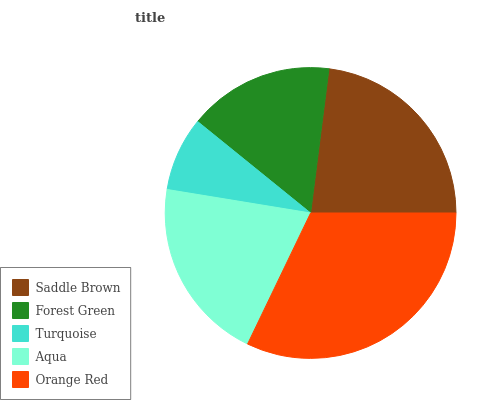Is Turquoise the minimum?
Answer yes or no. Yes. Is Orange Red the maximum?
Answer yes or no. Yes. Is Forest Green the minimum?
Answer yes or no. No. Is Forest Green the maximum?
Answer yes or no. No. Is Saddle Brown greater than Forest Green?
Answer yes or no. Yes. Is Forest Green less than Saddle Brown?
Answer yes or no. Yes. Is Forest Green greater than Saddle Brown?
Answer yes or no. No. Is Saddle Brown less than Forest Green?
Answer yes or no. No. Is Aqua the high median?
Answer yes or no. Yes. Is Aqua the low median?
Answer yes or no. Yes. Is Forest Green the high median?
Answer yes or no. No. Is Saddle Brown the low median?
Answer yes or no. No. 